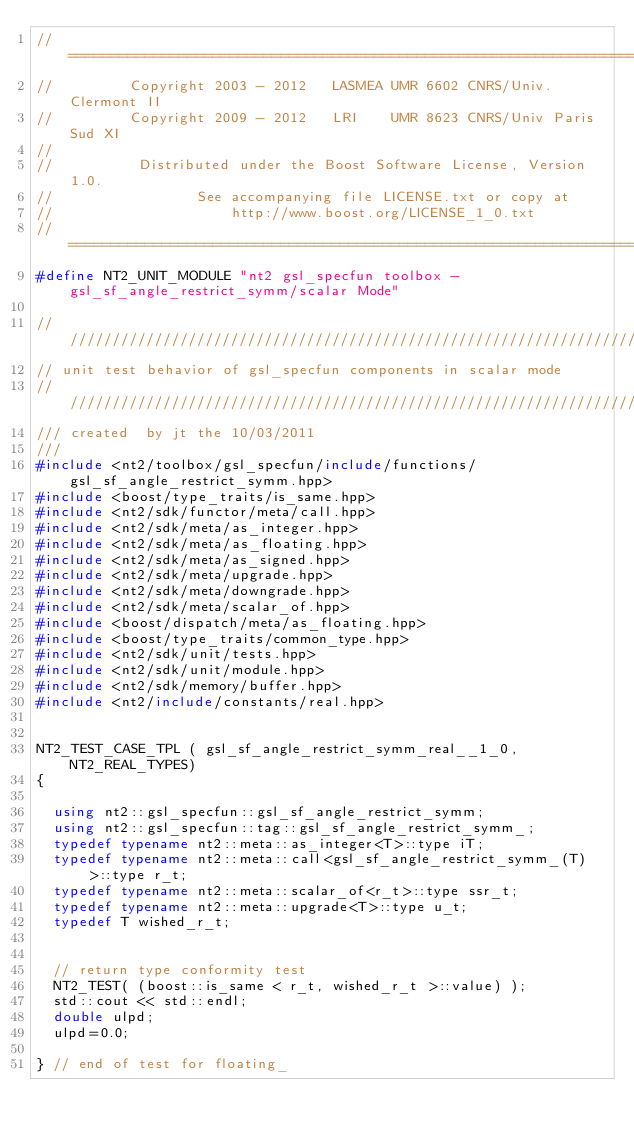<code> <loc_0><loc_0><loc_500><loc_500><_C++_>//==============================================================================
//         Copyright 2003 - 2012   LASMEA UMR 6602 CNRS/Univ. Clermont II
//         Copyright 2009 - 2012   LRI    UMR 8623 CNRS/Univ Paris Sud XI
//
//          Distributed under the Boost Software License, Version 1.0.
//                 See accompanying file LICENSE.txt or copy at
//                     http://www.boost.org/LICENSE_1_0.txt
//==============================================================================
#define NT2_UNIT_MODULE "nt2 gsl_specfun toolbox - gsl_sf_angle_restrict_symm/scalar Mode"

//////////////////////////////////////////////////////////////////////////////
// unit test behavior of gsl_specfun components in scalar mode
//////////////////////////////////////////////////////////////////////////////
/// created  by jt the 10/03/2011
///
#include <nt2/toolbox/gsl_specfun/include/functions/gsl_sf_angle_restrict_symm.hpp>
#include <boost/type_traits/is_same.hpp>
#include <nt2/sdk/functor/meta/call.hpp>
#include <nt2/sdk/meta/as_integer.hpp>
#include <nt2/sdk/meta/as_floating.hpp>
#include <nt2/sdk/meta/as_signed.hpp>
#include <nt2/sdk/meta/upgrade.hpp>
#include <nt2/sdk/meta/downgrade.hpp>
#include <nt2/sdk/meta/scalar_of.hpp>
#include <boost/dispatch/meta/as_floating.hpp>
#include <boost/type_traits/common_type.hpp>
#include <nt2/sdk/unit/tests.hpp>
#include <nt2/sdk/unit/module.hpp>
#include <nt2/sdk/memory/buffer.hpp>
#include <nt2/include/constants/real.hpp>


NT2_TEST_CASE_TPL ( gsl_sf_angle_restrict_symm_real__1_0,  NT2_REAL_TYPES)
{

  using nt2::gsl_specfun::gsl_sf_angle_restrict_symm;
  using nt2::gsl_specfun::tag::gsl_sf_angle_restrict_symm_;
  typedef typename nt2::meta::as_integer<T>::type iT;
  typedef typename nt2::meta::call<gsl_sf_angle_restrict_symm_(T)>::type r_t;
  typedef typename nt2::meta::scalar_of<r_t>::type ssr_t;
  typedef typename nt2::meta::upgrade<T>::type u_t;
  typedef T wished_r_t;


  // return type conformity test
  NT2_TEST( (boost::is_same < r_t, wished_r_t >::value) );
  std::cout << std::endl;
  double ulpd;
  ulpd=0.0;

} // end of test for floating_
</code> 